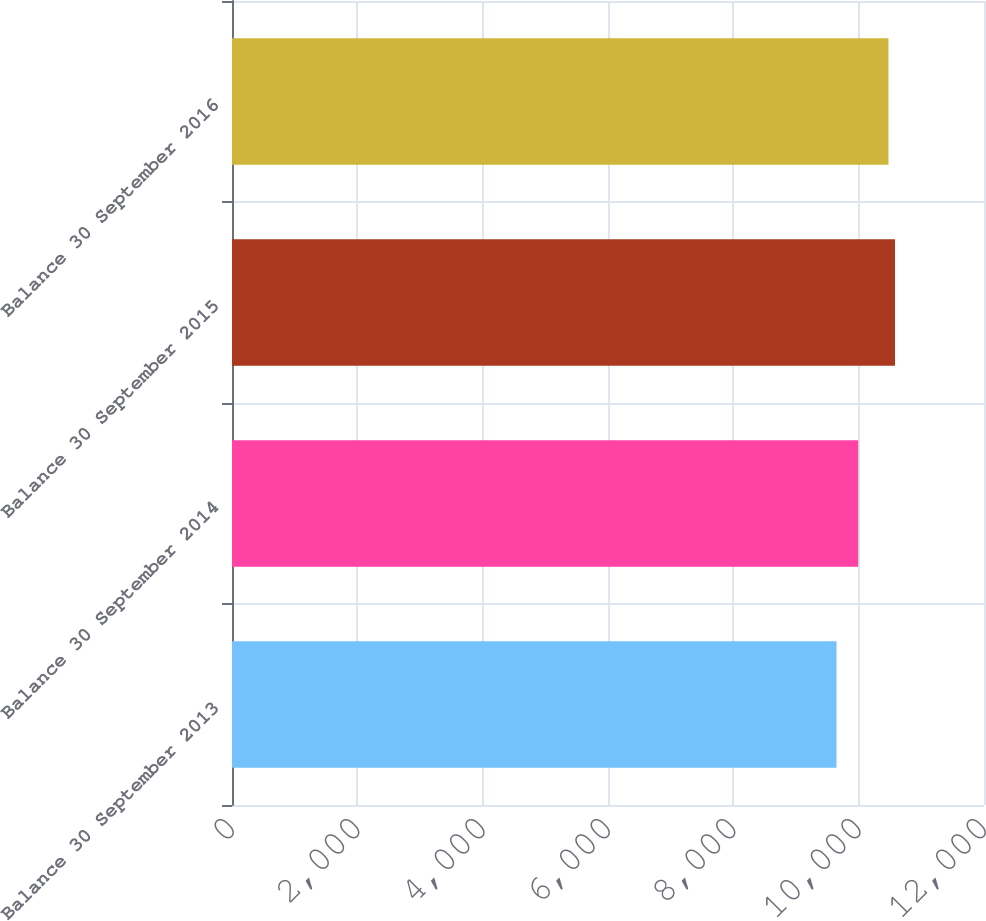Convert chart to OTSL. <chart><loc_0><loc_0><loc_500><loc_500><bar_chart><fcel>Balance 30 September 2013<fcel>Balance 30 September 2014<fcel>Balance 30 September 2015<fcel>Balance 30 September 2016<nl><fcel>9646.4<fcel>9993.2<fcel>10580.4<fcel>10475.5<nl></chart> 